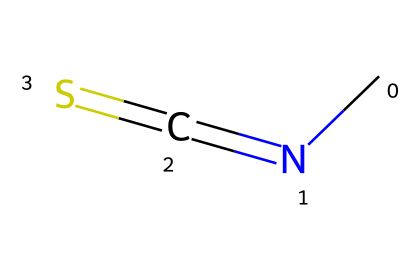how many atoms are in this molecule? The SMILES representation CN=C=S indicates there are four different atomic symbols: C (carbon), N (nitrogen), and S (sulfur). Counting each component gives us a total of four atoms: one carbon, one nitrogen, and one sulfur, plus one additional hydrogen from the NH part of the molecule.
Answer: four what type of bonds are present in this molecule? The bonding in the molecule is characterized by a double bond between carbon and nitrogen (C=N) and a double bond between carbon and sulfur (C=S). Therefore, the significant bonds present are one double bond between C and N and one double bond between C and S.
Answer: double bonds what is the hybridization of the carbon atom in this molecule? The carbon atom in the molecule is engaged in two double bonds, one with nitrogen and another with sulfur. This configuration typically leads to an sp hybridization due to the involvement of two different atoms with double bonds.
Answer: sp what is the overall charge of the molecule? The structure does not contain any explicit negative or positive charges in the SMILES representation, therefore, the overall molecule is neutral as there are no extra electrons or deficits indicated.
Answer: neutral which functional groups are present in this compound? The presence of a thiourea-like structure suggests that the functional groups in this compound are a thiourea functional group due to the presence of nitrogen (NH) and carbonyl characteristics, further confirmed by the participation of sulfur.
Answer: thiourea what characteristic property is associated with the presence of carbenes in soil fumigants? Carbenes, particularly in the context of soil fumigants, are known for their reactivity as they can act as nucleophiles and have strong abilities to interact with other molecules; this makes them effective in pest control within agricultural applications.
Answer: reactivity 